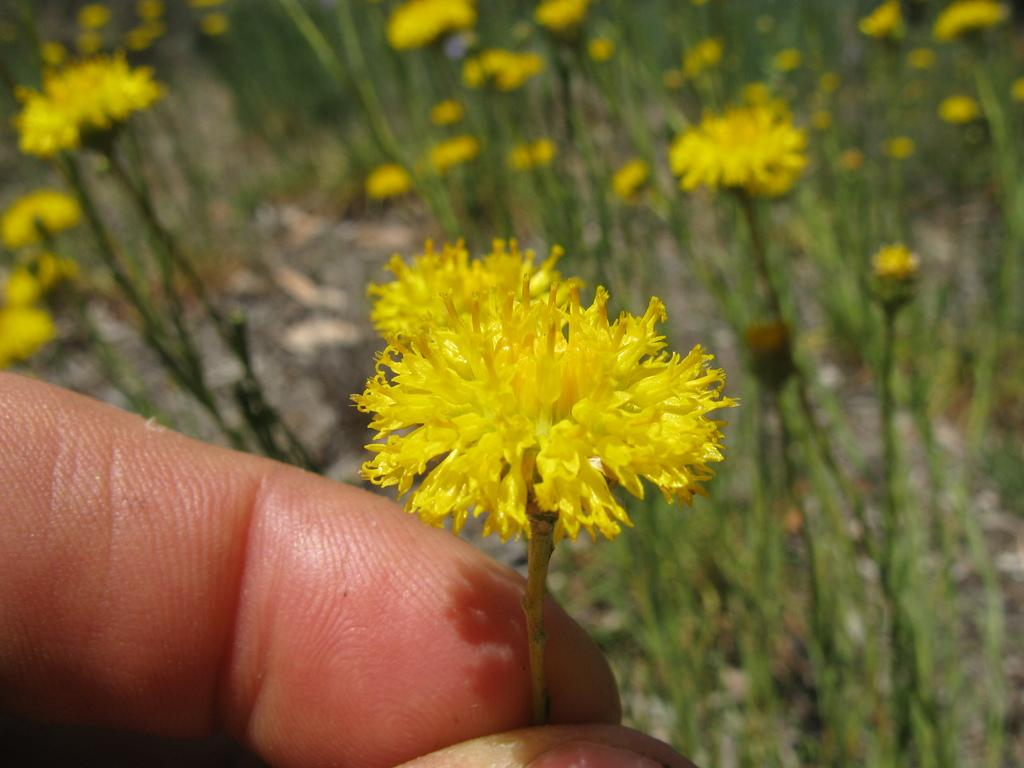Who is present in the image? There is a person in the image. What is the person holding? The person is holding a flower. What color are the flowers on the plants? The flowers on the plants are yellow. What type of cork can be seen in the image? There is no cork present in the image. Can you describe the bird that is perched on the person's shoulder in the image? There is no bird present in the image; the person is holding a flower. 